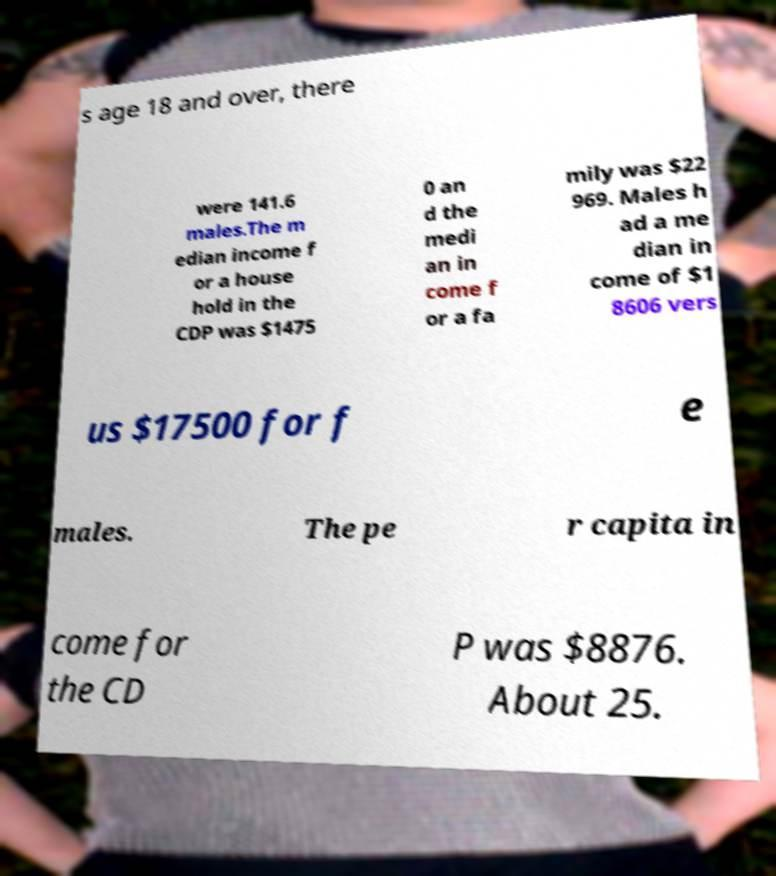Please identify and transcribe the text found in this image. s age 18 and over, there were 141.6 males.The m edian income f or a house hold in the CDP was $1475 0 an d the medi an in come f or a fa mily was $22 969. Males h ad a me dian in come of $1 8606 vers us $17500 for f e males. The pe r capita in come for the CD P was $8876. About 25. 